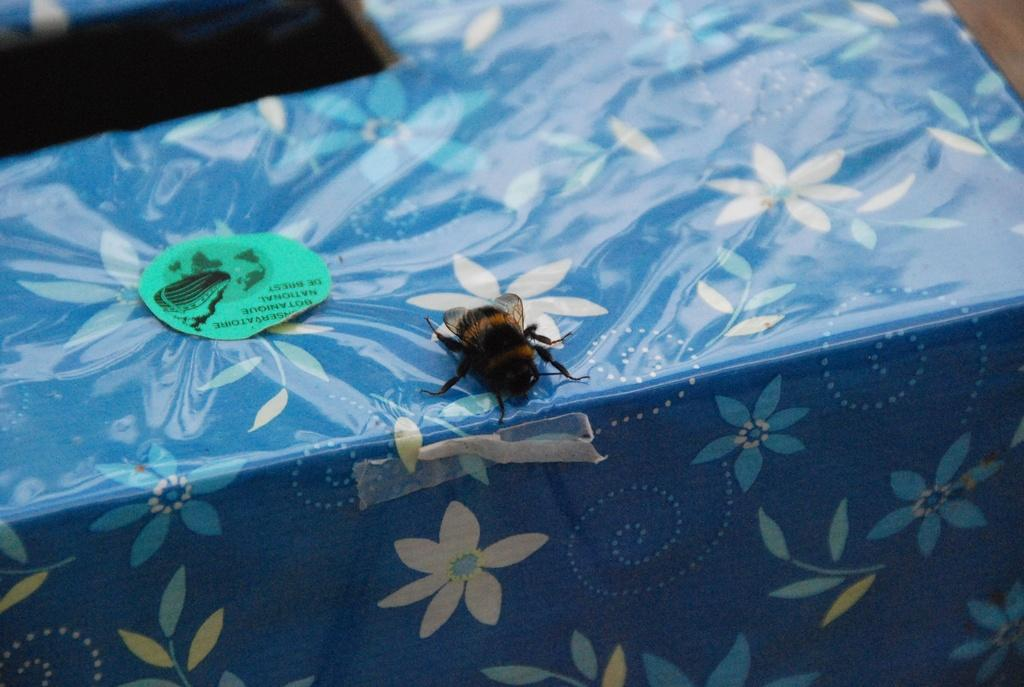What is on the box in the image? There is an insect on the box, and it has decorative paper attached to it. Are there any additional markings on the box? Yes, there is a sticker on the box. Where is the box located in the image? The box is on a table. What type of drain is visible in the image? There is no drain present in the image; it features a box with an insect, decorative paper, and a sticker. Can you describe the interaction between the bears and the box in the image? There are no bears present in the image; it only features a box with an insect, decorative paper, and a sticker. 